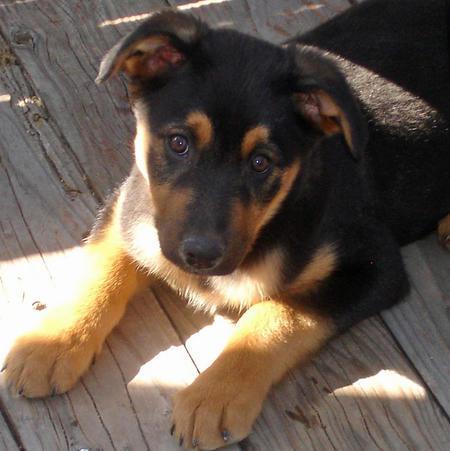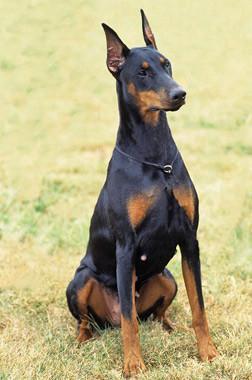The first image is the image on the left, the second image is the image on the right. For the images displayed, is the sentence "One dog is sitting and isn't wearing a dog collar." factually correct? Answer yes or no. No. The first image is the image on the left, the second image is the image on the right. Evaluate the accuracy of this statement regarding the images: "At least one image features an adult doberman with erect pointy ears in an upright sitting position.". Is it true? Answer yes or no. Yes. 